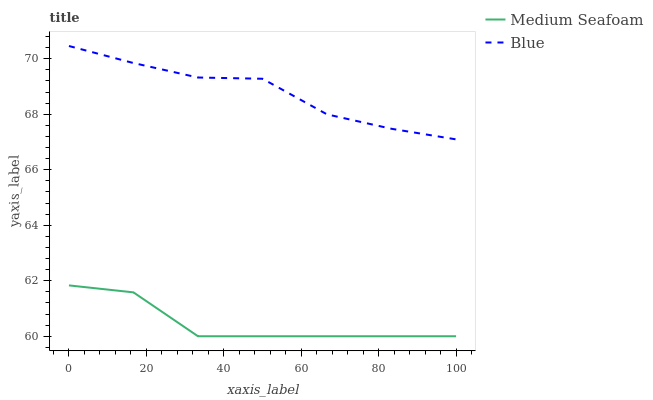Does Medium Seafoam have the minimum area under the curve?
Answer yes or no. Yes. Does Blue have the maximum area under the curve?
Answer yes or no. Yes. Does Medium Seafoam have the maximum area under the curve?
Answer yes or no. No. Is Blue the smoothest?
Answer yes or no. Yes. Is Medium Seafoam the roughest?
Answer yes or no. Yes. Is Medium Seafoam the smoothest?
Answer yes or no. No. Does Medium Seafoam have the highest value?
Answer yes or no. No. Is Medium Seafoam less than Blue?
Answer yes or no. Yes. Is Blue greater than Medium Seafoam?
Answer yes or no. Yes. Does Medium Seafoam intersect Blue?
Answer yes or no. No. 